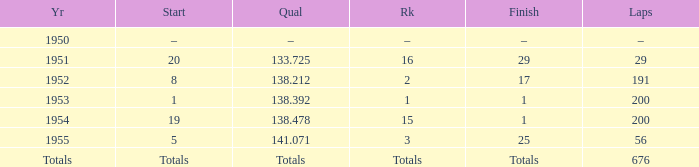What finish qualified at 141.071? 25.0. 